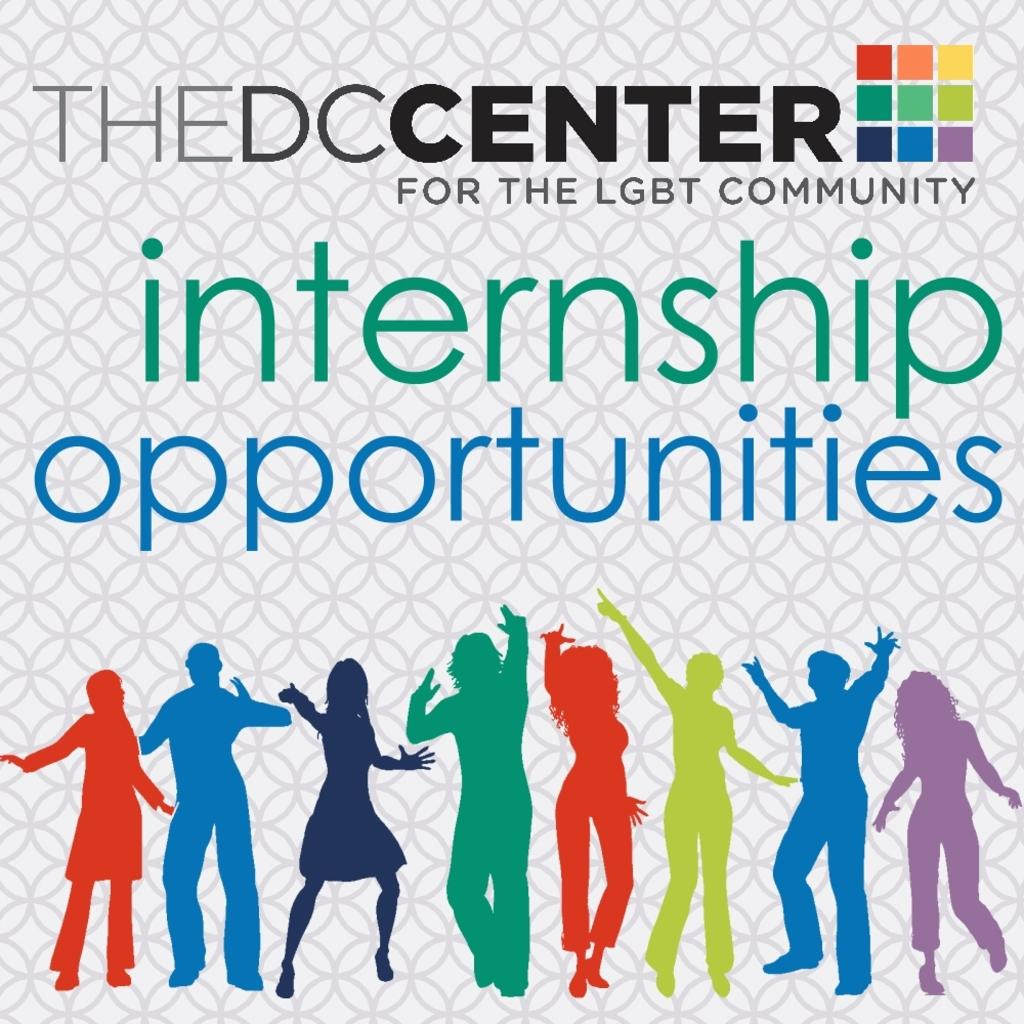What type of image is being described? The image is a poster. What can be seen on the poster? There are people in the poster representing the LGBT community. What is your uncle's temper like in the poster? There is no uncle present in the poster, as it features people representing the LGBT community. 